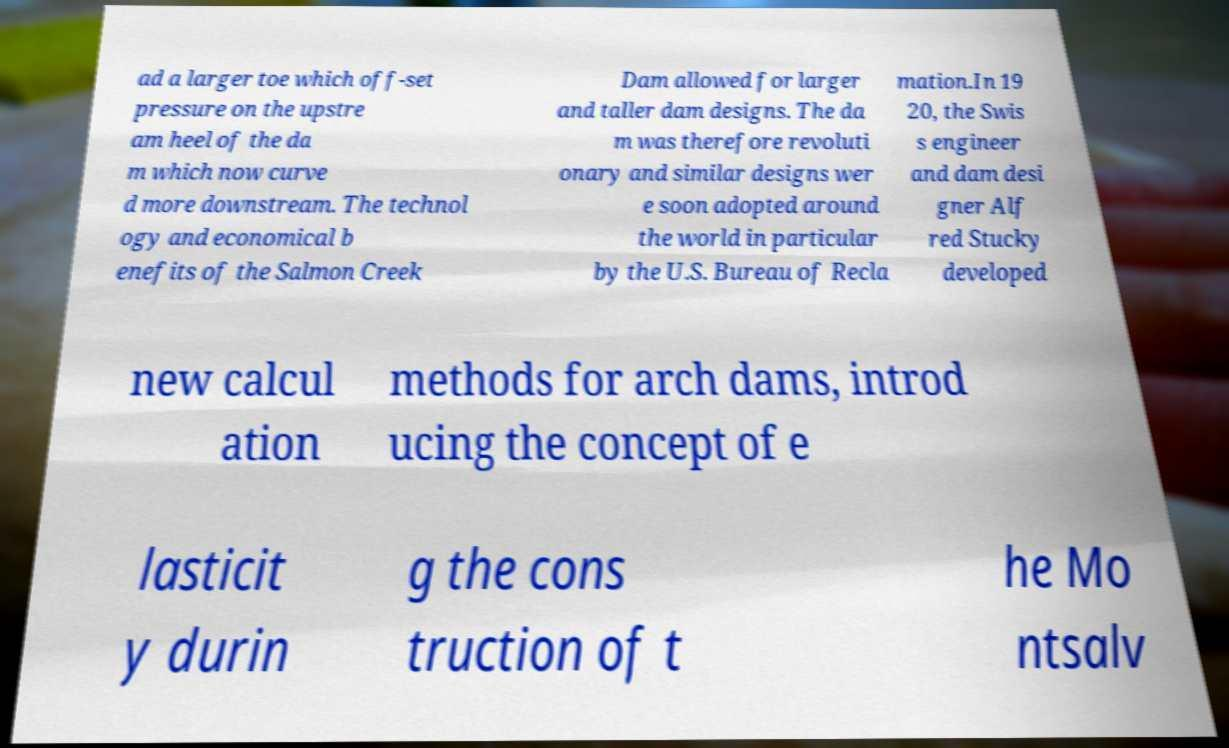For documentation purposes, I need the text within this image transcribed. Could you provide that? ad a larger toe which off-set pressure on the upstre am heel of the da m which now curve d more downstream. The technol ogy and economical b enefits of the Salmon Creek Dam allowed for larger and taller dam designs. The da m was therefore revoluti onary and similar designs wer e soon adopted around the world in particular by the U.S. Bureau of Recla mation.In 19 20, the Swis s engineer and dam desi gner Alf red Stucky developed new calcul ation methods for arch dams, introd ucing the concept of e lasticit y durin g the cons truction of t he Mo ntsalv 